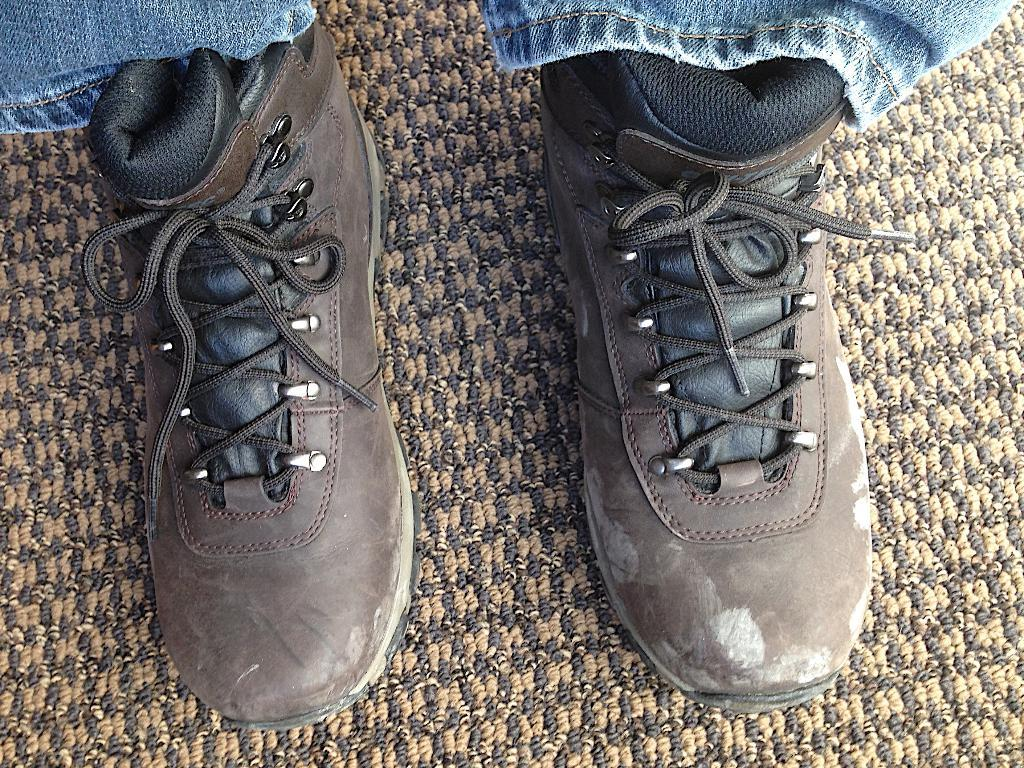What objects are present in the image? There are shoes in the image. Where are the shoes located? The shoes are on a mat. What type of wren can be seen wearing the skirt in the image? There is no wren or skirt present in the image; it only features shoes on a mat. 